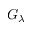<formula> <loc_0><loc_0><loc_500><loc_500>G _ { \lambda }</formula> 